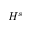Convert formula to latex. <formula><loc_0><loc_0><loc_500><loc_500>H ^ { s }</formula> 